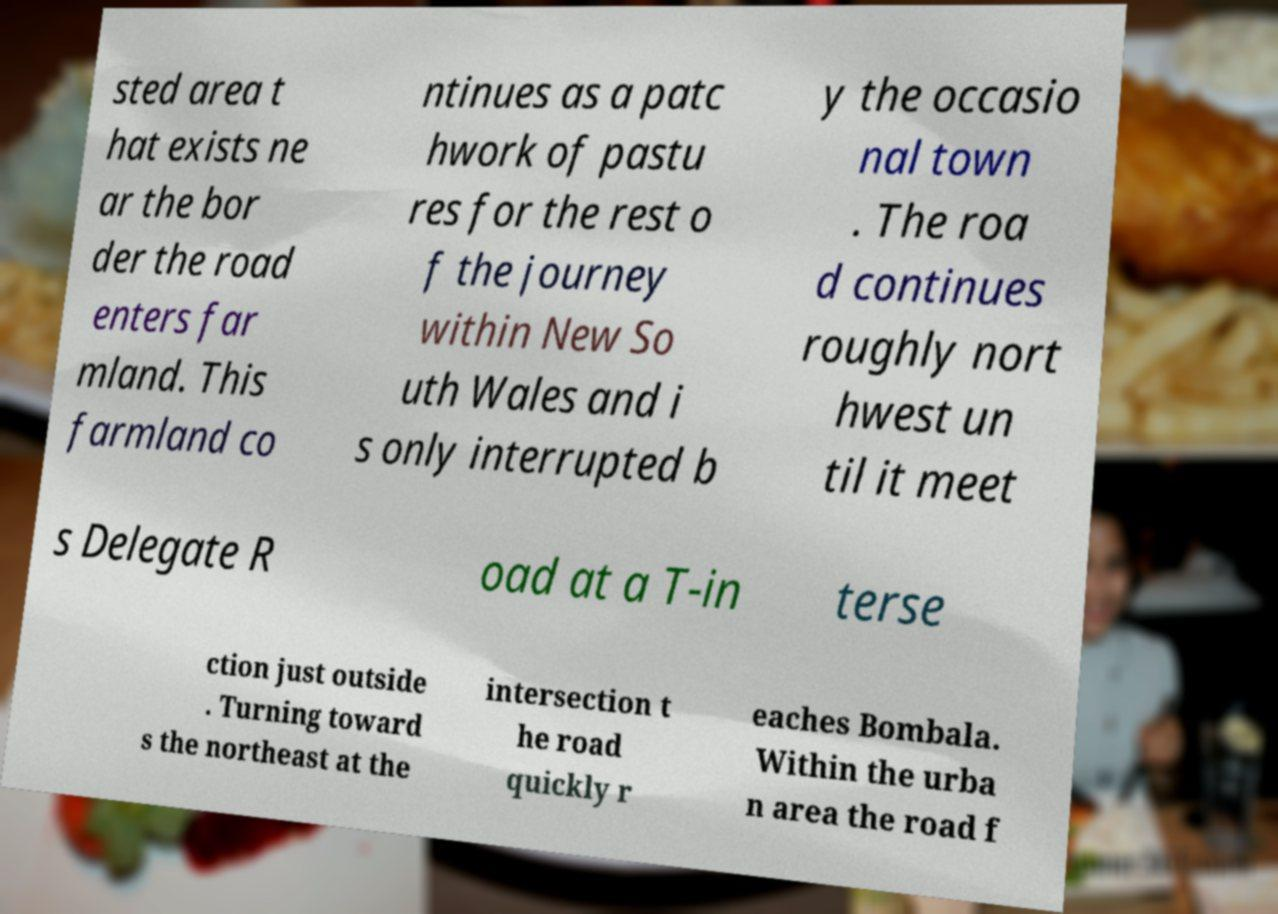There's text embedded in this image that I need extracted. Can you transcribe it verbatim? sted area t hat exists ne ar the bor der the road enters far mland. This farmland co ntinues as a patc hwork of pastu res for the rest o f the journey within New So uth Wales and i s only interrupted b y the occasio nal town . The roa d continues roughly nort hwest un til it meet s Delegate R oad at a T-in terse ction just outside . Turning toward s the northeast at the intersection t he road quickly r eaches Bombala. Within the urba n area the road f 